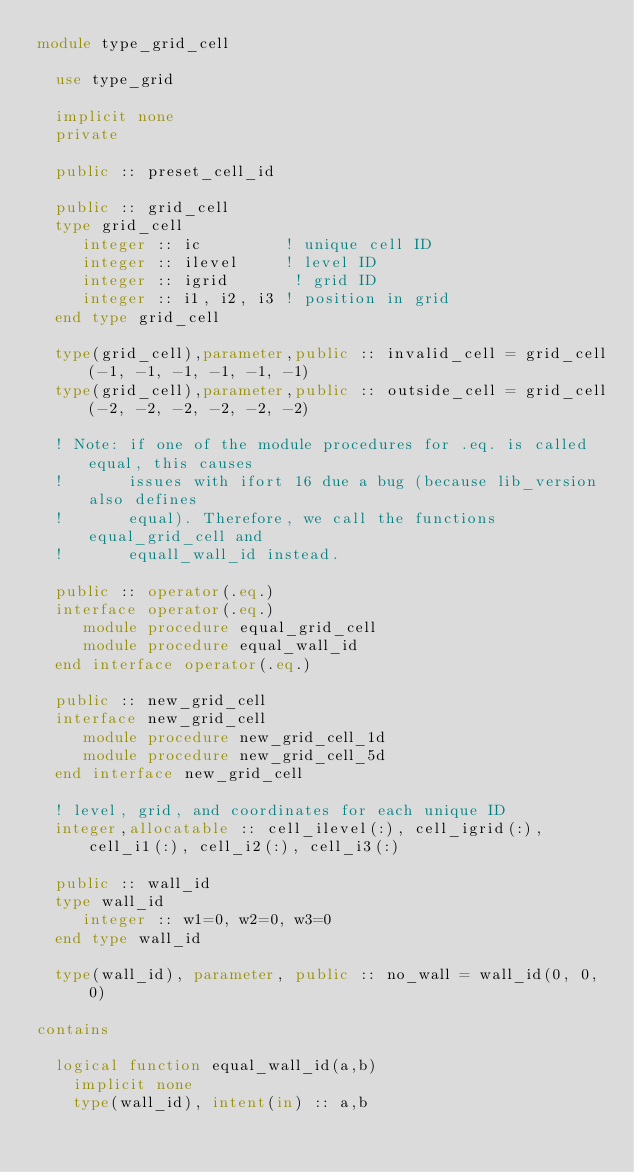<code> <loc_0><loc_0><loc_500><loc_500><_FORTRAN_>module type_grid_cell

  use type_grid

  implicit none
  private

  public :: preset_cell_id

  public :: grid_cell
  type grid_cell
     integer :: ic         ! unique cell ID
     integer :: ilevel     ! level ID
     integer :: igrid       ! grid ID
     integer :: i1, i2, i3 ! position in grid
  end type grid_cell

  type(grid_cell),parameter,public :: invalid_cell = grid_cell(-1, -1, -1, -1, -1, -1)
  type(grid_cell),parameter,public :: outside_cell = grid_cell(-2, -2, -2, -2, -2, -2)

  ! Note: if one of the module procedures for .eq. is called equal, this causes
  !       issues with ifort 16 due a bug (because lib_version also defines
  !       equal). Therefore, we call the functions equal_grid_cell and
  !       equall_wall_id instead.

  public :: operator(.eq.)
  interface operator(.eq.)
     module procedure equal_grid_cell
     module procedure equal_wall_id
  end interface operator(.eq.)

  public :: new_grid_cell
  interface new_grid_cell
     module procedure new_grid_cell_1d
     module procedure new_grid_cell_5d
  end interface new_grid_cell

  ! level, grid, and coordinates for each unique ID
  integer,allocatable :: cell_ilevel(:), cell_igrid(:), cell_i1(:), cell_i2(:), cell_i3(:)

  public :: wall_id
  type wall_id
     integer :: w1=0, w2=0, w3=0
  end type wall_id

  type(wall_id), parameter, public :: no_wall = wall_id(0, 0, 0)

contains

  logical function equal_wall_id(a,b)
    implicit none
    type(wall_id), intent(in) :: a,b</code> 